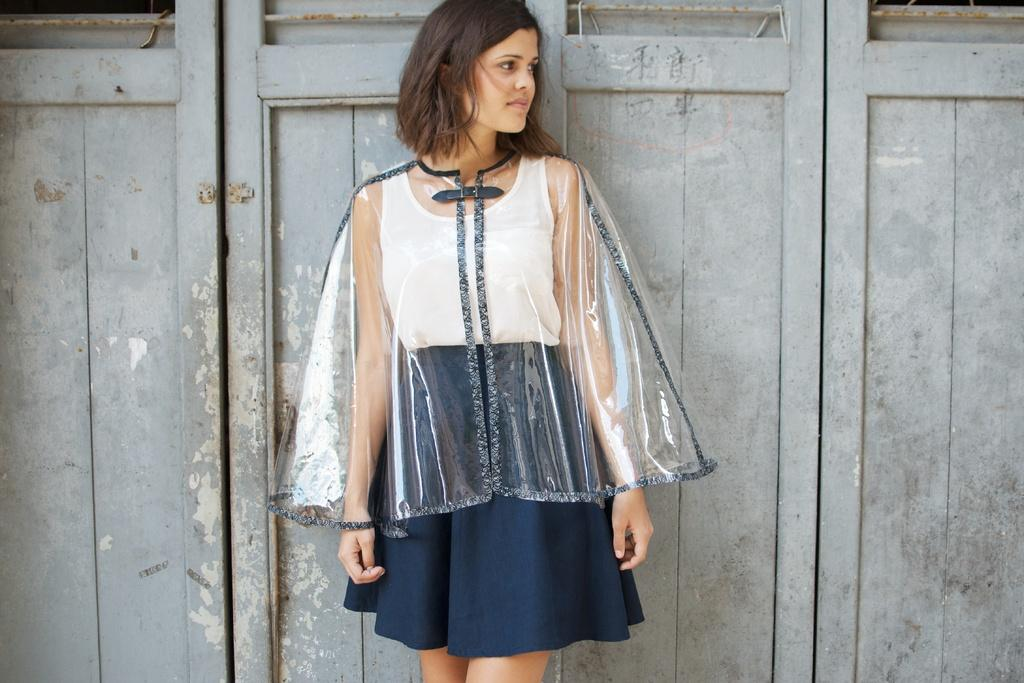What is the main subject of the image? There is a woman standing in the center of the image. What can be seen behind the woman? There are wooden doors behind the woman. What type of garden can be seen in the image? There is no garden present in the image; it features a woman standing in front of wooden doors. How can the woman join the soap in the image? There is no soap present in the image, so it is not possible for the woman to join it. 